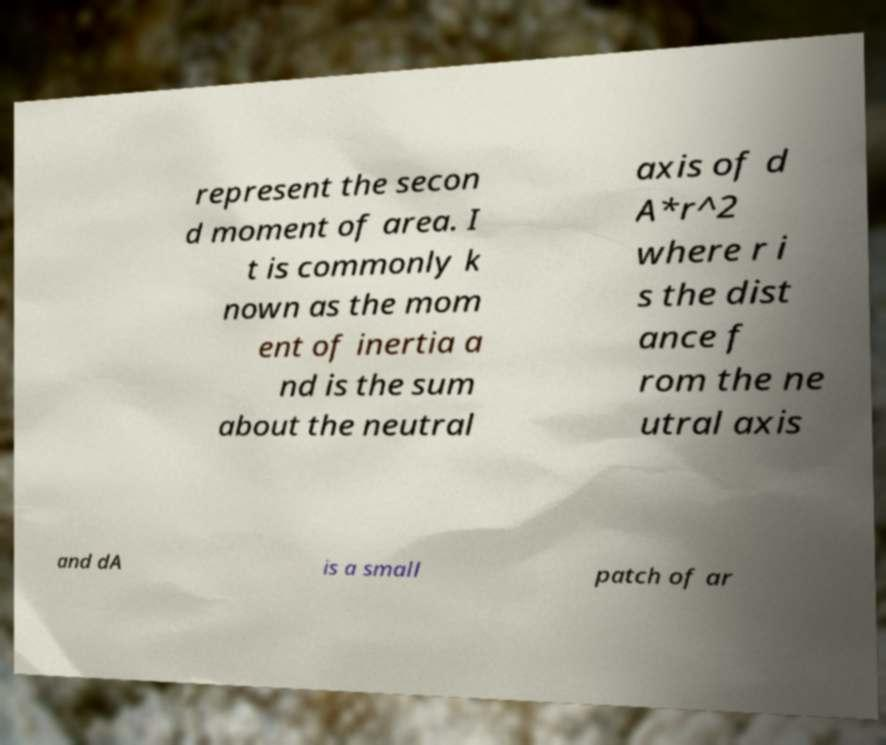Could you extract and type out the text from this image? represent the secon d moment of area. I t is commonly k nown as the mom ent of inertia a nd is the sum about the neutral axis of d A*r^2 where r i s the dist ance f rom the ne utral axis and dA is a small patch of ar 